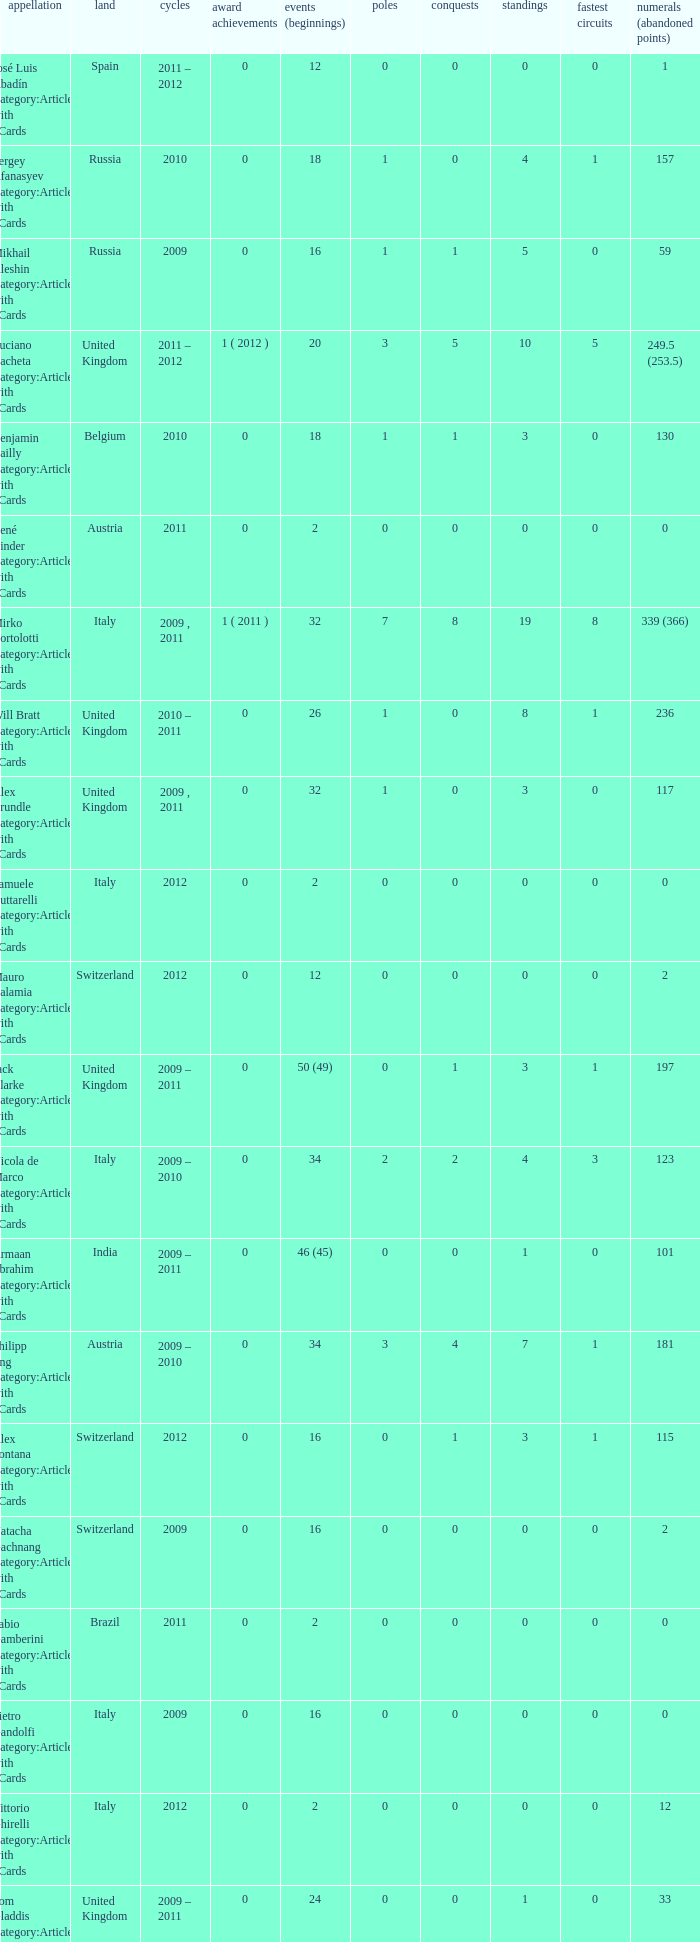Give me the full table as a dictionary. {'header': ['appellation', 'land', 'cycles', 'award achievements', 'events (beginnings)', 'poles', 'conquests', 'standings', 'fastest circuits', 'numerals (abandoned points)'], 'rows': [['José Luis Abadín Category:Articles with hCards', 'Spain', '2011 – 2012', '0', '12', '0', '0', '0', '0', '1'], ['Sergey Afanasyev Category:Articles with hCards', 'Russia', '2010', '0', '18', '1', '0', '4', '1', '157'], ['Mikhail Aleshin Category:Articles with hCards', 'Russia', '2009', '0', '16', '1', '1', '5', '0', '59'], ['Luciano Bacheta Category:Articles with hCards', 'United Kingdom', '2011 – 2012', '1 ( 2012 )', '20', '3', '5', '10', '5', '249.5 (253.5)'], ['Benjamin Bailly Category:Articles with hCards', 'Belgium', '2010', '0', '18', '1', '1', '3', '0', '130'], ['René Binder Category:Articles with hCards', 'Austria', '2011', '0', '2', '0', '0', '0', '0', '0'], ['Mirko Bortolotti Category:Articles with hCards', 'Italy', '2009 , 2011', '1 ( 2011 )', '32', '7', '8', '19', '8', '339 (366)'], ['Will Bratt Category:Articles with hCards', 'United Kingdom', '2010 – 2011', '0', '26', '1', '0', '8', '1', '236'], ['Alex Brundle Category:Articles with hCards', 'United Kingdom', '2009 , 2011', '0', '32', '1', '0', '3', '0', '117'], ['Samuele Buttarelli Category:Articles with hCards', 'Italy', '2012', '0', '2', '0', '0', '0', '0', '0'], ['Mauro Calamia Category:Articles with hCards', 'Switzerland', '2012', '0', '12', '0', '0', '0', '0', '2'], ['Jack Clarke Category:Articles with hCards', 'United Kingdom', '2009 – 2011', '0', '50 (49)', '0', '1', '3', '1', '197'], ['Nicola de Marco Category:Articles with hCards', 'Italy', '2009 – 2010', '0', '34', '2', '2', '4', '3', '123'], ['Armaan Ebrahim Category:Articles with hCards', 'India', '2009 – 2011', '0', '46 (45)', '0', '0', '1', '0', '101'], ['Philipp Eng Category:Articles with hCards', 'Austria', '2009 – 2010', '0', '34', '3', '4', '7', '1', '181'], ['Alex Fontana Category:Articles with hCards', 'Switzerland', '2012', '0', '16', '0', '1', '3', '1', '115'], ['Natacha Gachnang Category:Articles with hCards', 'Switzerland', '2009', '0', '16', '0', '0', '0', '0', '2'], ['Fabio Gamberini Category:Articles with hCards', 'Brazil', '2011', '0', '2', '0', '0', '0', '0', '0'], ['Pietro Gandolfi Category:Articles with hCards', 'Italy', '2009', '0', '16', '0', '0', '0', '0', '0'], ['Vittorio Ghirelli Category:Articles with hCards', 'Italy', '2012', '0', '2', '0', '0', '0', '0', '12'], ['Tom Gladdis Category:Articles with hCards', 'United Kingdom', '2009 – 2011', '0', '24', '0', '0', '1', '0', '33'], ['Richard Gonda Category:Articles with hCards', 'Slovakia', '2012', '0', '2', '0', '0', '0', '0', '4'], ['Victor Guerin Category:Articles with hCards', 'Brazil', '2012', '0', '2', '0', '0', '0', '0', '2'], ['Ollie Hancock Category:Articles with hCards', 'United Kingdom', '2009', '0', '6', '0', '0', '0', '0', '0'], ['Tobias Hegewald Category:Articles with hCards', 'Germany', '2009 , 2011', '0', '32', '4', '2', '5', '3', '158'], ['Sebastian Hohenthal Category:Articles with hCards', 'Sweden', '2009', '0', '16', '0', '0', '0', '0', '7'], ['Jens Höing Category:Articles with hCards', 'Germany', '2009', '0', '16', '0', '0', '0', '0', '0'], ['Hector Hurst Category:Articles with hCards', 'United Kingdom', '2012', '0', '16', '0', '0', '0', '0', '27'], ['Carlos Iaconelli Category:Articles with hCards', 'Brazil', '2009', '0', '14', '0', '0', '1', '0', '21'], ['Axcil Jefferies Category:Articles with hCards', 'Zimbabwe', '2012', '0', '12 (11)', '0', '0', '0', '0', '17'], ['Johan Jokinen Category:Articles with hCards', 'Denmark', '2010', '0', '6', '0', '0', '1', '1', '21'], ['Julien Jousse Category:Articles with hCards', 'France', '2009', '0', '16', '1', '1', '4', '2', '49'], ['Henri Karjalainen Category:Articles with hCards', 'Finland', '2009', '0', '16', '0', '0', '0', '0', '7'], ['Kourosh Khani Category:Articles with hCards', 'Iran', '2012', '0', '8', '0', '0', '0', '0', '2'], ['Jordan King Category:Articles with hCards', 'United Kingdom', '2011', '0', '6', '0', '0', '0', '0', '17'], ['Natalia Kowalska Category:Articles with hCards', 'Poland', '2010 – 2011', '0', '20', '0', '0', '0', '0', '3'], ['Plamen Kralev Category:Articles with hCards', 'Bulgaria', '2010 – 2012', '0', '50 (49)', '0', '0', '0', '0', '6'], ['Ajith Kumar Category:Articles with hCards', 'India', '2010', '0', '6', '0', '0', '0', '0', '0'], ['Jon Lancaster Category:Articles with hCards', 'United Kingdom', '2011', '0', '2', '0', '0', '0', '0', '14'], ['Benjamin Lariche Category:Articles with hCards', 'France', '2010 – 2011', '0', '34', '0', '0', '0', '0', '48'], ['Mikkel Mac Category:Articles with hCards', 'Denmark', '2011', '0', '16', '0', '0', '0', '0', '23'], ['Mihai Marinescu Category:Articles with hCards', 'Romania', '2010 – 2012', '0', '50', '4', '3', '8', '4', '299'], ['Daniel McKenzie Category:Articles with hCards', 'United Kingdom', '2012', '0', '16', '0', '0', '2', '0', '95'], ['Kevin Mirocha Category:Articles with hCards', 'Poland', '2012', '0', '16', '1', '1', '6', '0', '159.5'], ['Miki Monrás Category:Articles with hCards', 'Spain', '2011', '0', '16', '1', '1', '4', '1', '153'], ['Jason Moore Category:Articles with hCards', 'United Kingdom', '2009', '0', '16 (15)', '0', '0', '0', '0', '3'], ['Sung-Hak Mun Category:Articles with hCards', 'South Korea', '2011', '0', '16 (15)', '0', '0', '0', '0', '0'], ['Jolyon Palmer Category:Articles with hCards', 'United Kingdom', '2009 – 2010', '0', '34 (36)', '5', '5', '10', '3', '245'], ['Miloš Pavlović Category:Articles with hCards', 'Serbia', '2009', '0', '16', '0', '0', '2', '1', '29'], ['Ramón Piñeiro Category:Articles with hCards', 'Spain', '2010 – 2011', '0', '18', '2', '3', '7', '2', '186'], ['Markus Pommer Category:Articles with hCards', 'Germany', '2012', '0', '16', '4', '3', '5', '2', '169'], ['Edoardo Piscopo Category:Articles with hCards', 'Italy', '2009', '0', '14', '0', '0', '0', '0', '19'], ['Paul Rees Category:Articles with hCards', 'United Kingdom', '2010', '0', '8', '0', '0', '0', '0', '18'], ['Ivan Samarin Category:Articles with hCards', 'Russia', '2010', '0', '18', '0', '0', '0', '0', '64'], ['Germán Sánchez Category:Articles with hCards', 'Spain', '2009', '0', '16 (14)', '0', '0', '0', '0', '2'], ['Harald Schlegelmilch Category:Articles with hCards', 'Latvia', '2012', '0', '2', '0', '0', '0', '0', '12'], ['Max Snegirev Category:Articles with hCards', 'Russia', '2011 – 2012', '0', '28', '0', '0', '0', '0', '20'], ['Kelvin Snoeks Category:Articles with hCards', 'Netherlands', '2010 – 2011', '0', '32', '0', '0', '1', '0', '88'], ['Andy Soucek Category:Articles with hCards', 'Spain', '2009', '1 ( 2009 )', '16', '2', '7', '11', '3', '115'], ['Dean Stoneman Category:Articles with hCards', 'United Kingdom', '2010', '1 ( 2010 )', '18', '6', '6', '13', '6', '284'], ['Thiemo Storz Category:Articles with hCards', 'Germany', '2011', '0', '16', '0', '0', '0', '0', '19'], ['Parthiva Sureshwaren Category:Articles with hCards', 'India', '2010 – 2012', '0', '32 (31)', '0', '0', '0', '0', '1'], ['Henry Surtees Category:Articles with hCards', 'United Kingdom', '2009', '0', '8', '1', '0', '1', '0', '8'], ['Ricardo Teixeira Category:Articles with hCards', 'Angola', '2010', '0', '18', '0', '0', '0', '0', '23'], ['Johannes Theobald Category:Articles with hCards', 'Germany', '2010 – 2011', '0', '14', '0', '0', '0', '0', '1'], ['Julian Theobald Category:Articles with hCards', 'Germany', '2010 – 2011', '0', '18', '0', '0', '0', '0', '8'], ['Mathéo Tuscher Category:Articles with hCards', 'Switzerland', '2012', '0', '16', '4', '2', '9', '1', '210'], ['Tristan Vautier Category:Articles with hCards', 'France', '2009', '0', '2', '0', '0', '1', '0', '9'], ['Kazim Vasiliauskas Category:Articles with hCards', 'Lithuania', '2009 – 2010', '0', '34', '3', '2', '10', '4', '198'], ['Robert Wickens Category:Articles with hCards', 'Canada', '2009', '0', '16', '5', '2', '6', '3', '64'], ['Dino Zamparelli Category:Articles with hCards', 'United Kingdom', '2012', '0', '16', '0', '0', '2', '0', '106.5'], ['Christopher Zanella Category:Articles with hCards', 'Switzerland', '2011 – 2012', '0', '32', '3', '4', '14', '5', '385 (401)']]} What is the minimum amount of poles? 0.0. 